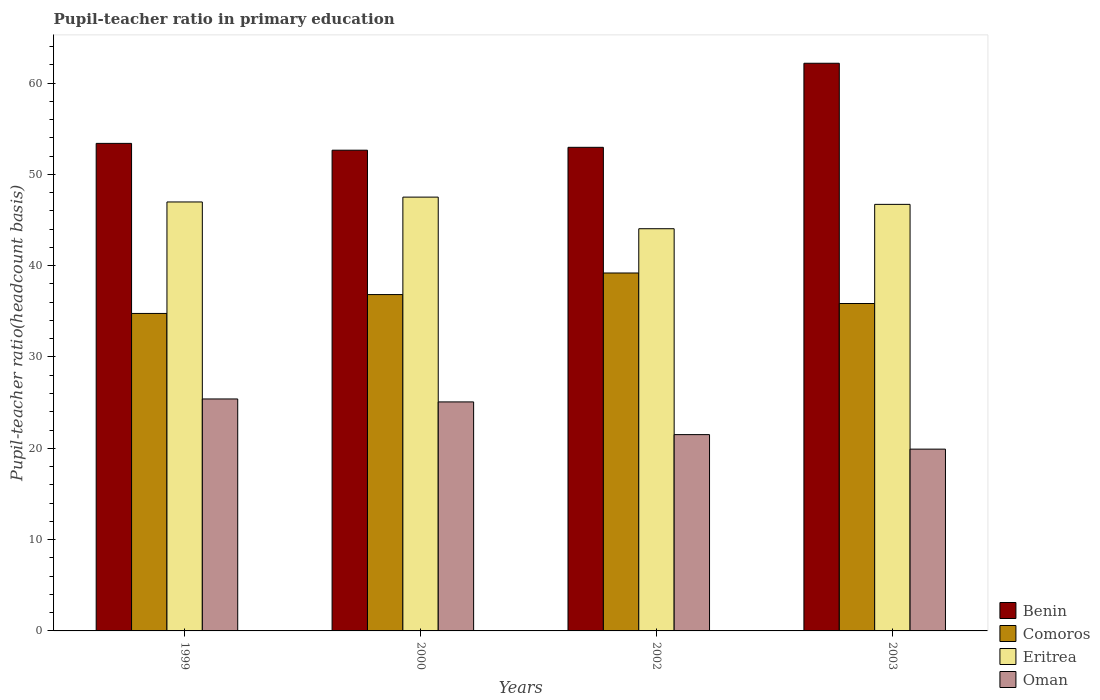How many different coloured bars are there?
Your answer should be very brief. 4. How many bars are there on the 3rd tick from the right?
Offer a terse response. 4. In how many cases, is the number of bars for a given year not equal to the number of legend labels?
Provide a short and direct response. 0. What is the pupil-teacher ratio in primary education in Benin in 2003?
Keep it short and to the point. 62.17. Across all years, what is the maximum pupil-teacher ratio in primary education in Eritrea?
Your response must be concise. 47.51. Across all years, what is the minimum pupil-teacher ratio in primary education in Benin?
Provide a short and direct response. 52.65. In which year was the pupil-teacher ratio in primary education in Eritrea maximum?
Your answer should be very brief. 2000. What is the total pupil-teacher ratio in primary education in Comoros in the graph?
Provide a succinct answer. 146.67. What is the difference between the pupil-teacher ratio in primary education in Oman in 1999 and that in 2000?
Your response must be concise. 0.32. What is the difference between the pupil-teacher ratio in primary education in Benin in 2000 and the pupil-teacher ratio in primary education in Eritrea in 2003?
Make the answer very short. 5.93. What is the average pupil-teacher ratio in primary education in Oman per year?
Offer a terse response. 22.97. In the year 2003, what is the difference between the pupil-teacher ratio in primary education in Comoros and pupil-teacher ratio in primary education in Oman?
Your response must be concise. 15.95. What is the ratio of the pupil-teacher ratio in primary education in Oman in 1999 to that in 2000?
Make the answer very short. 1.01. Is the pupil-teacher ratio in primary education in Oman in 1999 less than that in 2000?
Provide a short and direct response. No. Is the difference between the pupil-teacher ratio in primary education in Comoros in 1999 and 2000 greater than the difference between the pupil-teacher ratio in primary education in Oman in 1999 and 2000?
Provide a succinct answer. No. What is the difference between the highest and the second highest pupil-teacher ratio in primary education in Oman?
Provide a succinct answer. 0.32. What is the difference between the highest and the lowest pupil-teacher ratio in primary education in Oman?
Keep it short and to the point. 5.5. In how many years, is the pupil-teacher ratio in primary education in Comoros greater than the average pupil-teacher ratio in primary education in Comoros taken over all years?
Your response must be concise. 2. Is it the case that in every year, the sum of the pupil-teacher ratio in primary education in Comoros and pupil-teacher ratio in primary education in Eritrea is greater than the sum of pupil-teacher ratio in primary education in Benin and pupil-teacher ratio in primary education in Oman?
Give a very brief answer. Yes. What does the 3rd bar from the left in 2002 represents?
Your answer should be very brief. Eritrea. What does the 2nd bar from the right in 2002 represents?
Your response must be concise. Eritrea. Is it the case that in every year, the sum of the pupil-teacher ratio in primary education in Benin and pupil-teacher ratio in primary education in Eritrea is greater than the pupil-teacher ratio in primary education in Oman?
Make the answer very short. Yes. How many bars are there?
Your response must be concise. 16. How many years are there in the graph?
Make the answer very short. 4. What is the difference between two consecutive major ticks on the Y-axis?
Ensure brevity in your answer.  10. Does the graph contain any zero values?
Your answer should be very brief. No. Does the graph contain grids?
Provide a succinct answer. No. How many legend labels are there?
Provide a succinct answer. 4. How are the legend labels stacked?
Provide a short and direct response. Vertical. What is the title of the graph?
Make the answer very short. Pupil-teacher ratio in primary education. Does "Panama" appear as one of the legend labels in the graph?
Offer a terse response. No. What is the label or title of the Y-axis?
Offer a terse response. Pupil-teacher ratio(headcount basis). What is the Pupil-teacher ratio(headcount basis) of Benin in 1999?
Give a very brief answer. 53.4. What is the Pupil-teacher ratio(headcount basis) in Comoros in 1999?
Give a very brief answer. 34.77. What is the Pupil-teacher ratio(headcount basis) of Eritrea in 1999?
Offer a terse response. 46.98. What is the Pupil-teacher ratio(headcount basis) of Oman in 1999?
Offer a very short reply. 25.41. What is the Pupil-teacher ratio(headcount basis) of Benin in 2000?
Make the answer very short. 52.65. What is the Pupil-teacher ratio(headcount basis) of Comoros in 2000?
Your answer should be compact. 36.84. What is the Pupil-teacher ratio(headcount basis) of Eritrea in 2000?
Give a very brief answer. 47.51. What is the Pupil-teacher ratio(headcount basis) in Oman in 2000?
Make the answer very short. 25.08. What is the Pupil-teacher ratio(headcount basis) in Benin in 2002?
Offer a very short reply. 52.96. What is the Pupil-teacher ratio(headcount basis) in Comoros in 2002?
Ensure brevity in your answer.  39.2. What is the Pupil-teacher ratio(headcount basis) in Eritrea in 2002?
Make the answer very short. 44.05. What is the Pupil-teacher ratio(headcount basis) in Oman in 2002?
Provide a short and direct response. 21.5. What is the Pupil-teacher ratio(headcount basis) of Benin in 2003?
Offer a terse response. 62.17. What is the Pupil-teacher ratio(headcount basis) in Comoros in 2003?
Ensure brevity in your answer.  35.86. What is the Pupil-teacher ratio(headcount basis) of Eritrea in 2003?
Offer a terse response. 46.72. What is the Pupil-teacher ratio(headcount basis) of Oman in 2003?
Give a very brief answer. 19.91. Across all years, what is the maximum Pupil-teacher ratio(headcount basis) in Benin?
Offer a terse response. 62.17. Across all years, what is the maximum Pupil-teacher ratio(headcount basis) in Comoros?
Offer a terse response. 39.2. Across all years, what is the maximum Pupil-teacher ratio(headcount basis) of Eritrea?
Your answer should be very brief. 47.51. Across all years, what is the maximum Pupil-teacher ratio(headcount basis) in Oman?
Offer a terse response. 25.41. Across all years, what is the minimum Pupil-teacher ratio(headcount basis) of Benin?
Offer a very short reply. 52.65. Across all years, what is the minimum Pupil-teacher ratio(headcount basis) of Comoros?
Give a very brief answer. 34.77. Across all years, what is the minimum Pupil-teacher ratio(headcount basis) in Eritrea?
Your response must be concise. 44.05. Across all years, what is the minimum Pupil-teacher ratio(headcount basis) of Oman?
Offer a very short reply. 19.91. What is the total Pupil-teacher ratio(headcount basis) in Benin in the graph?
Keep it short and to the point. 221.18. What is the total Pupil-teacher ratio(headcount basis) in Comoros in the graph?
Give a very brief answer. 146.67. What is the total Pupil-teacher ratio(headcount basis) of Eritrea in the graph?
Ensure brevity in your answer.  185.26. What is the total Pupil-teacher ratio(headcount basis) of Oman in the graph?
Offer a very short reply. 91.89. What is the difference between the Pupil-teacher ratio(headcount basis) of Benin in 1999 and that in 2000?
Provide a succinct answer. 0.75. What is the difference between the Pupil-teacher ratio(headcount basis) in Comoros in 1999 and that in 2000?
Provide a short and direct response. -2.07. What is the difference between the Pupil-teacher ratio(headcount basis) in Eritrea in 1999 and that in 2000?
Provide a succinct answer. -0.53. What is the difference between the Pupil-teacher ratio(headcount basis) in Oman in 1999 and that in 2000?
Your answer should be compact. 0.32. What is the difference between the Pupil-teacher ratio(headcount basis) of Benin in 1999 and that in 2002?
Provide a short and direct response. 0.43. What is the difference between the Pupil-teacher ratio(headcount basis) of Comoros in 1999 and that in 2002?
Provide a succinct answer. -4.43. What is the difference between the Pupil-teacher ratio(headcount basis) of Eritrea in 1999 and that in 2002?
Make the answer very short. 2.93. What is the difference between the Pupil-teacher ratio(headcount basis) of Oman in 1999 and that in 2002?
Offer a terse response. 3.91. What is the difference between the Pupil-teacher ratio(headcount basis) in Benin in 1999 and that in 2003?
Offer a terse response. -8.77. What is the difference between the Pupil-teacher ratio(headcount basis) of Comoros in 1999 and that in 2003?
Your answer should be compact. -1.09. What is the difference between the Pupil-teacher ratio(headcount basis) in Eritrea in 1999 and that in 2003?
Give a very brief answer. 0.26. What is the difference between the Pupil-teacher ratio(headcount basis) in Oman in 1999 and that in 2003?
Your answer should be very brief. 5.5. What is the difference between the Pupil-teacher ratio(headcount basis) of Benin in 2000 and that in 2002?
Ensure brevity in your answer.  -0.31. What is the difference between the Pupil-teacher ratio(headcount basis) of Comoros in 2000 and that in 2002?
Keep it short and to the point. -2.36. What is the difference between the Pupil-teacher ratio(headcount basis) in Eritrea in 2000 and that in 2002?
Offer a very short reply. 3.46. What is the difference between the Pupil-teacher ratio(headcount basis) in Oman in 2000 and that in 2002?
Your answer should be compact. 3.58. What is the difference between the Pupil-teacher ratio(headcount basis) of Benin in 2000 and that in 2003?
Offer a very short reply. -9.52. What is the difference between the Pupil-teacher ratio(headcount basis) of Comoros in 2000 and that in 2003?
Your response must be concise. 0.98. What is the difference between the Pupil-teacher ratio(headcount basis) of Eritrea in 2000 and that in 2003?
Your answer should be very brief. 0.79. What is the difference between the Pupil-teacher ratio(headcount basis) of Oman in 2000 and that in 2003?
Give a very brief answer. 5.17. What is the difference between the Pupil-teacher ratio(headcount basis) in Benin in 2002 and that in 2003?
Your answer should be compact. -9.21. What is the difference between the Pupil-teacher ratio(headcount basis) in Comoros in 2002 and that in 2003?
Offer a terse response. 3.34. What is the difference between the Pupil-teacher ratio(headcount basis) of Eritrea in 2002 and that in 2003?
Your response must be concise. -2.67. What is the difference between the Pupil-teacher ratio(headcount basis) of Oman in 2002 and that in 2003?
Your answer should be very brief. 1.59. What is the difference between the Pupil-teacher ratio(headcount basis) in Benin in 1999 and the Pupil-teacher ratio(headcount basis) in Comoros in 2000?
Keep it short and to the point. 16.56. What is the difference between the Pupil-teacher ratio(headcount basis) of Benin in 1999 and the Pupil-teacher ratio(headcount basis) of Eritrea in 2000?
Your response must be concise. 5.89. What is the difference between the Pupil-teacher ratio(headcount basis) of Benin in 1999 and the Pupil-teacher ratio(headcount basis) of Oman in 2000?
Your answer should be very brief. 28.31. What is the difference between the Pupil-teacher ratio(headcount basis) in Comoros in 1999 and the Pupil-teacher ratio(headcount basis) in Eritrea in 2000?
Ensure brevity in your answer.  -12.74. What is the difference between the Pupil-teacher ratio(headcount basis) in Comoros in 1999 and the Pupil-teacher ratio(headcount basis) in Oman in 2000?
Offer a terse response. 9.69. What is the difference between the Pupil-teacher ratio(headcount basis) of Eritrea in 1999 and the Pupil-teacher ratio(headcount basis) of Oman in 2000?
Provide a succinct answer. 21.9. What is the difference between the Pupil-teacher ratio(headcount basis) in Benin in 1999 and the Pupil-teacher ratio(headcount basis) in Comoros in 2002?
Give a very brief answer. 14.19. What is the difference between the Pupil-teacher ratio(headcount basis) of Benin in 1999 and the Pupil-teacher ratio(headcount basis) of Eritrea in 2002?
Provide a succinct answer. 9.35. What is the difference between the Pupil-teacher ratio(headcount basis) in Benin in 1999 and the Pupil-teacher ratio(headcount basis) in Oman in 2002?
Offer a very short reply. 31.9. What is the difference between the Pupil-teacher ratio(headcount basis) of Comoros in 1999 and the Pupil-teacher ratio(headcount basis) of Eritrea in 2002?
Your answer should be compact. -9.28. What is the difference between the Pupil-teacher ratio(headcount basis) in Comoros in 1999 and the Pupil-teacher ratio(headcount basis) in Oman in 2002?
Your answer should be compact. 13.27. What is the difference between the Pupil-teacher ratio(headcount basis) of Eritrea in 1999 and the Pupil-teacher ratio(headcount basis) of Oman in 2002?
Offer a very short reply. 25.48. What is the difference between the Pupil-teacher ratio(headcount basis) of Benin in 1999 and the Pupil-teacher ratio(headcount basis) of Comoros in 2003?
Provide a short and direct response. 17.54. What is the difference between the Pupil-teacher ratio(headcount basis) in Benin in 1999 and the Pupil-teacher ratio(headcount basis) in Eritrea in 2003?
Keep it short and to the point. 6.68. What is the difference between the Pupil-teacher ratio(headcount basis) in Benin in 1999 and the Pupil-teacher ratio(headcount basis) in Oman in 2003?
Keep it short and to the point. 33.49. What is the difference between the Pupil-teacher ratio(headcount basis) of Comoros in 1999 and the Pupil-teacher ratio(headcount basis) of Eritrea in 2003?
Provide a succinct answer. -11.95. What is the difference between the Pupil-teacher ratio(headcount basis) in Comoros in 1999 and the Pupil-teacher ratio(headcount basis) in Oman in 2003?
Provide a succinct answer. 14.86. What is the difference between the Pupil-teacher ratio(headcount basis) of Eritrea in 1999 and the Pupil-teacher ratio(headcount basis) of Oman in 2003?
Your answer should be compact. 27.07. What is the difference between the Pupil-teacher ratio(headcount basis) of Benin in 2000 and the Pupil-teacher ratio(headcount basis) of Comoros in 2002?
Provide a short and direct response. 13.45. What is the difference between the Pupil-teacher ratio(headcount basis) of Benin in 2000 and the Pupil-teacher ratio(headcount basis) of Eritrea in 2002?
Offer a terse response. 8.6. What is the difference between the Pupil-teacher ratio(headcount basis) in Benin in 2000 and the Pupil-teacher ratio(headcount basis) in Oman in 2002?
Provide a succinct answer. 31.15. What is the difference between the Pupil-teacher ratio(headcount basis) in Comoros in 2000 and the Pupil-teacher ratio(headcount basis) in Eritrea in 2002?
Provide a succinct answer. -7.21. What is the difference between the Pupil-teacher ratio(headcount basis) in Comoros in 2000 and the Pupil-teacher ratio(headcount basis) in Oman in 2002?
Give a very brief answer. 15.34. What is the difference between the Pupil-teacher ratio(headcount basis) of Eritrea in 2000 and the Pupil-teacher ratio(headcount basis) of Oman in 2002?
Keep it short and to the point. 26.01. What is the difference between the Pupil-teacher ratio(headcount basis) of Benin in 2000 and the Pupil-teacher ratio(headcount basis) of Comoros in 2003?
Your response must be concise. 16.79. What is the difference between the Pupil-teacher ratio(headcount basis) of Benin in 2000 and the Pupil-teacher ratio(headcount basis) of Eritrea in 2003?
Your response must be concise. 5.93. What is the difference between the Pupil-teacher ratio(headcount basis) in Benin in 2000 and the Pupil-teacher ratio(headcount basis) in Oman in 2003?
Offer a terse response. 32.74. What is the difference between the Pupil-teacher ratio(headcount basis) of Comoros in 2000 and the Pupil-teacher ratio(headcount basis) of Eritrea in 2003?
Give a very brief answer. -9.88. What is the difference between the Pupil-teacher ratio(headcount basis) in Comoros in 2000 and the Pupil-teacher ratio(headcount basis) in Oman in 2003?
Make the answer very short. 16.93. What is the difference between the Pupil-teacher ratio(headcount basis) in Eritrea in 2000 and the Pupil-teacher ratio(headcount basis) in Oman in 2003?
Provide a short and direct response. 27.6. What is the difference between the Pupil-teacher ratio(headcount basis) in Benin in 2002 and the Pupil-teacher ratio(headcount basis) in Comoros in 2003?
Provide a succinct answer. 17.11. What is the difference between the Pupil-teacher ratio(headcount basis) of Benin in 2002 and the Pupil-teacher ratio(headcount basis) of Eritrea in 2003?
Provide a succinct answer. 6.25. What is the difference between the Pupil-teacher ratio(headcount basis) in Benin in 2002 and the Pupil-teacher ratio(headcount basis) in Oman in 2003?
Offer a terse response. 33.05. What is the difference between the Pupil-teacher ratio(headcount basis) in Comoros in 2002 and the Pupil-teacher ratio(headcount basis) in Eritrea in 2003?
Give a very brief answer. -7.52. What is the difference between the Pupil-teacher ratio(headcount basis) of Comoros in 2002 and the Pupil-teacher ratio(headcount basis) of Oman in 2003?
Provide a succinct answer. 19.29. What is the difference between the Pupil-teacher ratio(headcount basis) of Eritrea in 2002 and the Pupil-teacher ratio(headcount basis) of Oman in 2003?
Make the answer very short. 24.14. What is the average Pupil-teacher ratio(headcount basis) in Benin per year?
Ensure brevity in your answer.  55.29. What is the average Pupil-teacher ratio(headcount basis) of Comoros per year?
Your answer should be compact. 36.67. What is the average Pupil-teacher ratio(headcount basis) of Eritrea per year?
Ensure brevity in your answer.  46.31. What is the average Pupil-teacher ratio(headcount basis) of Oman per year?
Make the answer very short. 22.97. In the year 1999, what is the difference between the Pupil-teacher ratio(headcount basis) in Benin and Pupil-teacher ratio(headcount basis) in Comoros?
Offer a terse response. 18.62. In the year 1999, what is the difference between the Pupil-teacher ratio(headcount basis) in Benin and Pupil-teacher ratio(headcount basis) in Eritrea?
Your answer should be compact. 6.42. In the year 1999, what is the difference between the Pupil-teacher ratio(headcount basis) of Benin and Pupil-teacher ratio(headcount basis) of Oman?
Offer a very short reply. 27.99. In the year 1999, what is the difference between the Pupil-teacher ratio(headcount basis) of Comoros and Pupil-teacher ratio(headcount basis) of Eritrea?
Give a very brief answer. -12.21. In the year 1999, what is the difference between the Pupil-teacher ratio(headcount basis) in Comoros and Pupil-teacher ratio(headcount basis) in Oman?
Your answer should be compact. 9.37. In the year 1999, what is the difference between the Pupil-teacher ratio(headcount basis) of Eritrea and Pupil-teacher ratio(headcount basis) of Oman?
Keep it short and to the point. 21.58. In the year 2000, what is the difference between the Pupil-teacher ratio(headcount basis) of Benin and Pupil-teacher ratio(headcount basis) of Comoros?
Your response must be concise. 15.81. In the year 2000, what is the difference between the Pupil-teacher ratio(headcount basis) in Benin and Pupil-teacher ratio(headcount basis) in Eritrea?
Offer a terse response. 5.14. In the year 2000, what is the difference between the Pupil-teacher ratio(headcount basis) in Benin and Pupil-teacher ratio(headcount basis) in Oman?
Give a very brief answer. 27.57. In the year 2000, what is the difference between the Pupil-teacher ratio(headcount basis) in Comoros and Pupil-teacher ratio(headcount basis) in Eritrea?
Provide a succinct answer. -10.67. In the year 2000, what is the difference between the Pupil-teacher ratio(headcount basis) in Comoros and Pupil-teacher ratio(headcount basis) in Oman?
Give a very brief answer. 11.76. In the year 2000, what is the difference between the Pupil-teacher ratio(headcount basis) of Eritrea and Pupil-teacher ratio(headcount basis) of Oman?
Give a very brief answer. 22.43. In the year 2002, what is the difference between the Pupil-teacher ratio(headcount basis) of Benin and Pupil-teacher ratio(headcount basis) of Comoros?
Offer a terse response. 13.76. In the year 2002, what is the difference between the Pupil-teacher ratio(headcount basis) in Benin and Pupil-teacher ratio(headcount basis) in Eritrea?
Your response must be concise. 8.91. In the year 2002, what is the difference between the Pupil-teacher ratio(headcount basis) in Benin and Pupil-teacher ratio(headcount basis) in Oman?
Give a very brief answer. 31.46. In the year 2002, what is the difference between the Pupil-teacher ratio(headcount basis) of Comoros and Pupil-teacher ratio(headcount basis) of Eritrea?
Your response must be concise. -4.85. In the year 2002, what is the difference between the Pupil-teacher ratio(headcount basis) in Comoros and Pupil-teacher ratio(headcount basis) in Oman?
Your response must be concise. 17.7. In the year 2002, what is the difference between the Pupil-teacher ratio(headcount basis) in Eritrea and Pupil-teacher ratio(headcount basis) in Oman?
Ensure brevity in your answer.  22.55. In the year 2003, what is the difference between the Pupil-teacher ratio(headcount basis) in Benin and Pupil-teacher ratio(headcount basis) in Comoros?
Provide a short and direct response. 26.31. In the year 2003, what is the difference between the Pupil-teacher ratio(headcount basis) of Benin and Pupil-teacher ratio(headcount basis) of Eritrea?
Your response must be concise. 15.45. In the year 2003, what is the difference between the Pupil-teacher ratio(headcount basis) of Benin and Pupil-teacher ratio(headcount basis) of Oman?
Offer a terse response. 42.26. In the year 2003, what is the difference between the Pupil-teacher ratio(headcount basis) in Comoros and Pupil-teacher ratio(headcount basis) in Eritrea?
Keep it short and to the point. -10.86. In the year 2003, what is the difference between the Pupil-teacher ratio(headcount basis) in Comoros and Pupil-teacher ratio(headcount basis) in Oman?
Your answer should be compact. 15.95. In the year 2003, what is the difference between the Pupil-teacher ratio(headcount basis) of Eritrea and Pupil-teacher ratio(headcount basis) of Oman?
Make the answer very short. 26.81. What is the ratio of the Pupil-teacher ratio(headcount basis) of Benin in 1999 to that in 2000?
Keep it short and to the point. 1.01. What is the ratio of the Pupil-teacher ratio(headcount basis) in Comoros in 1999 to that in 2000?
Keep it short and to the point. 0.94. What is the ratio of the Pupil-teacher ratio(headcount basis) of Oman in 1999 to that in 2000?
Your answer should be very brief. 1.01. What is the ratio of the Pupil-teacher ratio(headcount basis) in Benin in 1999 to that in 2002?
Give a very brief answer. 1.01. What is the ratio of the Pupil-teacher ratio(headcount basis) in Comoros in 1999 to that in 2002?
Your answer should be compact. 0.89. What is the ratio of the Pupil-teacher ratio(headcount basis) in Eritrea in 1999 to that in 2002?
Your answer should be compact. 1.07. What is the ratio of the Pupil-teacher ratio(headcount basis) in Oman in 1999 to that in 2002?
Your answer should be very brief. 1.18. What is the ratio of the Pupil-teacher ratio(headcount basis) in Benin in 1999 to that in 2003?
Your answer should be compact. 0.86. What is the ratio of the Pupil-teacher ratio(headcount basis) of Comoros in 1999 to that in 2003?
Ensure brevity in your answer.  0.97. What is the ratio of the Pupil-teacher ratio(headcount basis) in Eritrea in 1999 to that in 2003?
Provide a succinct answer. 1.01. What is the ratio of the Pupil-teacher ratio(headcount basis) of Oman in 1999 to that in 2003?
Your response must be concise. 1.28. What is the ratio of the Pupil-teacher ratio(headcount basis) in Comoros in 2000 to that in 2002?
Your answer should be compact. 0.94. What is the ratio of the Pupil-teacher ratio(headcount basis) in Eritrea in 2000 to that in 2002?
Your response must be concise. 1.08. What is the ratio of the Pupil-teacher ratio(headcount basis) in Oman in 2000 to that in 2002?
Provide a short and direct response. 1.17. What is the ratio of the Pupil-teacher ratio(headcount basis) of Benin in 2000 to that in 2003?
Keep it short and to the point. 0.85. What is the ratio of the Pupil-teacher ratio(headcount basis) of Comoros in 2000 to that in 2003?
Your answer should be very brief. 1.03. What is the ratio of the Pupil-teacher ratio(headcount basis) in Eritrea in 2000 to that in 2003?
Offer a very short reply. 1.02. What is the ratio of the Pupil-teacher ratio(headcount basis) in Oman in 2000 to that in 2003?
Offer a very short reply. 1.26. What is the ratio of the Pupil-teacher ratio(headcount basis) in Benin in 2002 to that in 2003?
Give a very brief answer. 0.85. What is the ratio of the Pupil-teacher ratio(headcount basis) in Comoros in 2002 to that in 2003?
Your response must be concise. 1.09. What is the ratio of the Pupil-teacher ratio(headcount basis) of Eritrea in 2002 to that in 2003?
Ensure brevity in your answer.  0.94. What is the ratio of the Pupil-teacher ratio(headcount basis) in Oman in 2002 to that in 2003?
Make the answer very short. 1.08. What is the difference between the highest and the second highest Pupil-teacher ratio(headcount basis) of Benin?
Your answer should be very brief. 8.77. What is the difference between the highest and the second highest Pupil-teacher ratio(headcount basis) in Comoros?
Make the answer very short. 2.36. What is the difference between the highest and the second highest Pupil-teacher ratio(headcount basis) of Eritrea?
Give a very brief answer. 0.53. What is the difference between the highest and the second highest Pupil-teacher ratio(headcount basis) of Oman?
Provide a short and direct response. 0.32. What is the difference between the highest and the lowest Pupil-teacher ratio(headcount basis) of Benin?
Your response must be concise. 9.52. What is the difference between the highest and the lowest Pupil-teacher ratio(headcount basis) of Comoros?
Offer a very short reply. 4.43. What is the difference between the highest and the lowest Pupil-teacher ratio(headcount basis) of Eritrea?
Offer a terse response. 3.46. What is the difference between the highest and the lowest Pupil-teacher ratio(headcount basis) in Oman?
Your answer should be compact. 5.5. 